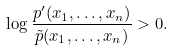Convert formula to latex. <formula><loc_0><loc_0><loc_500><loc_500>\log \frac { p ^ { \prime } ( x _ { 1 } , \dots , x _ { n } ) } { \tilde { p } ( x _ { 1 } , \dots , x _ { n } ) } > 0 .</formula> 